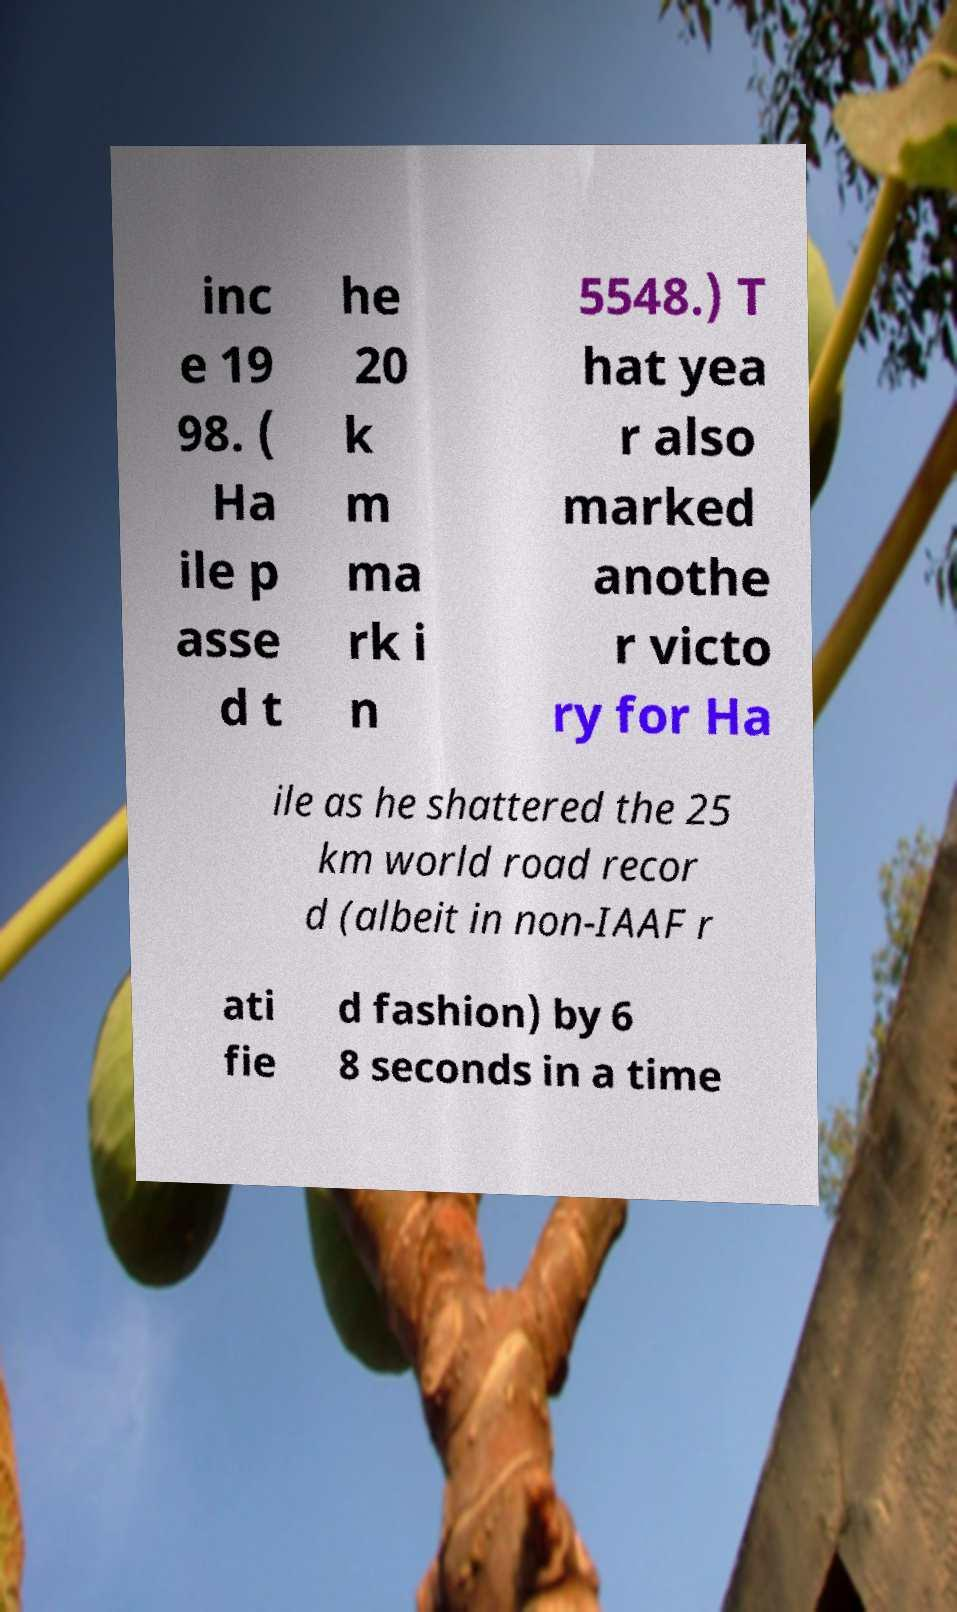Could you assist in decoding the text presented in this image and type it out clearly? inc e 19 98. ( Ha ile p asse d t he 20 k m ma rk i n 5548.) T hat yea r also marked anothe r victo ry for Ha ile as he shattered the 25 km world road recor d (albeit in non-IAAF r ati fie d fashion) by 6 8 seconds in a time 